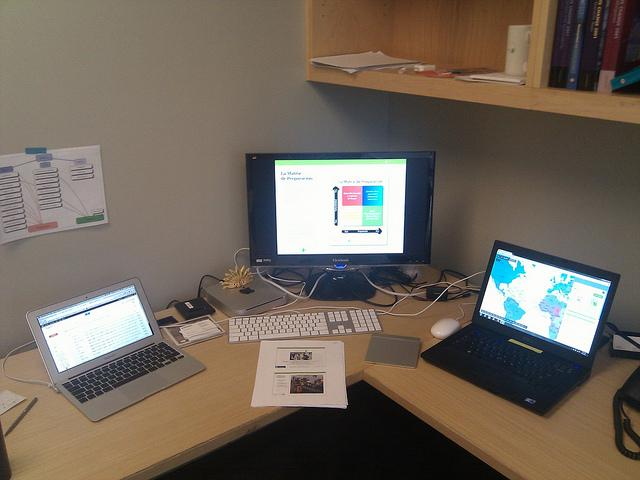On which computer could one find directions the fastest? Please explain your reasoning. right. A map is shown in a computer screen to the right of other computers. 